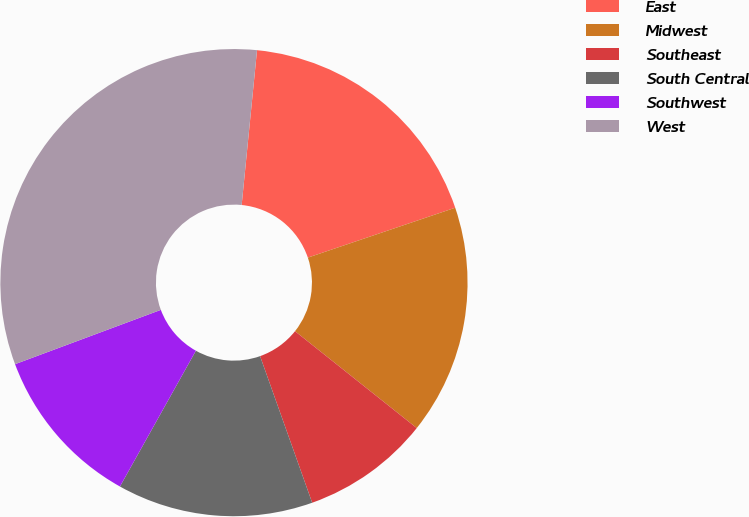Convert chart to OTSL. <chart><loc_0><loc_0><loc_500><loc_500><pie_chart><fcel>East<fcel>Midwest<fcel>Southeast<fcel>South Central<fcel>Southwest<fcel>West<nl><fcel>18.23%<fcel>15.89%<fcel>8.87%<fcel>13.55%<fcel>11.21%<fcel>32.25%<nl></chart> 